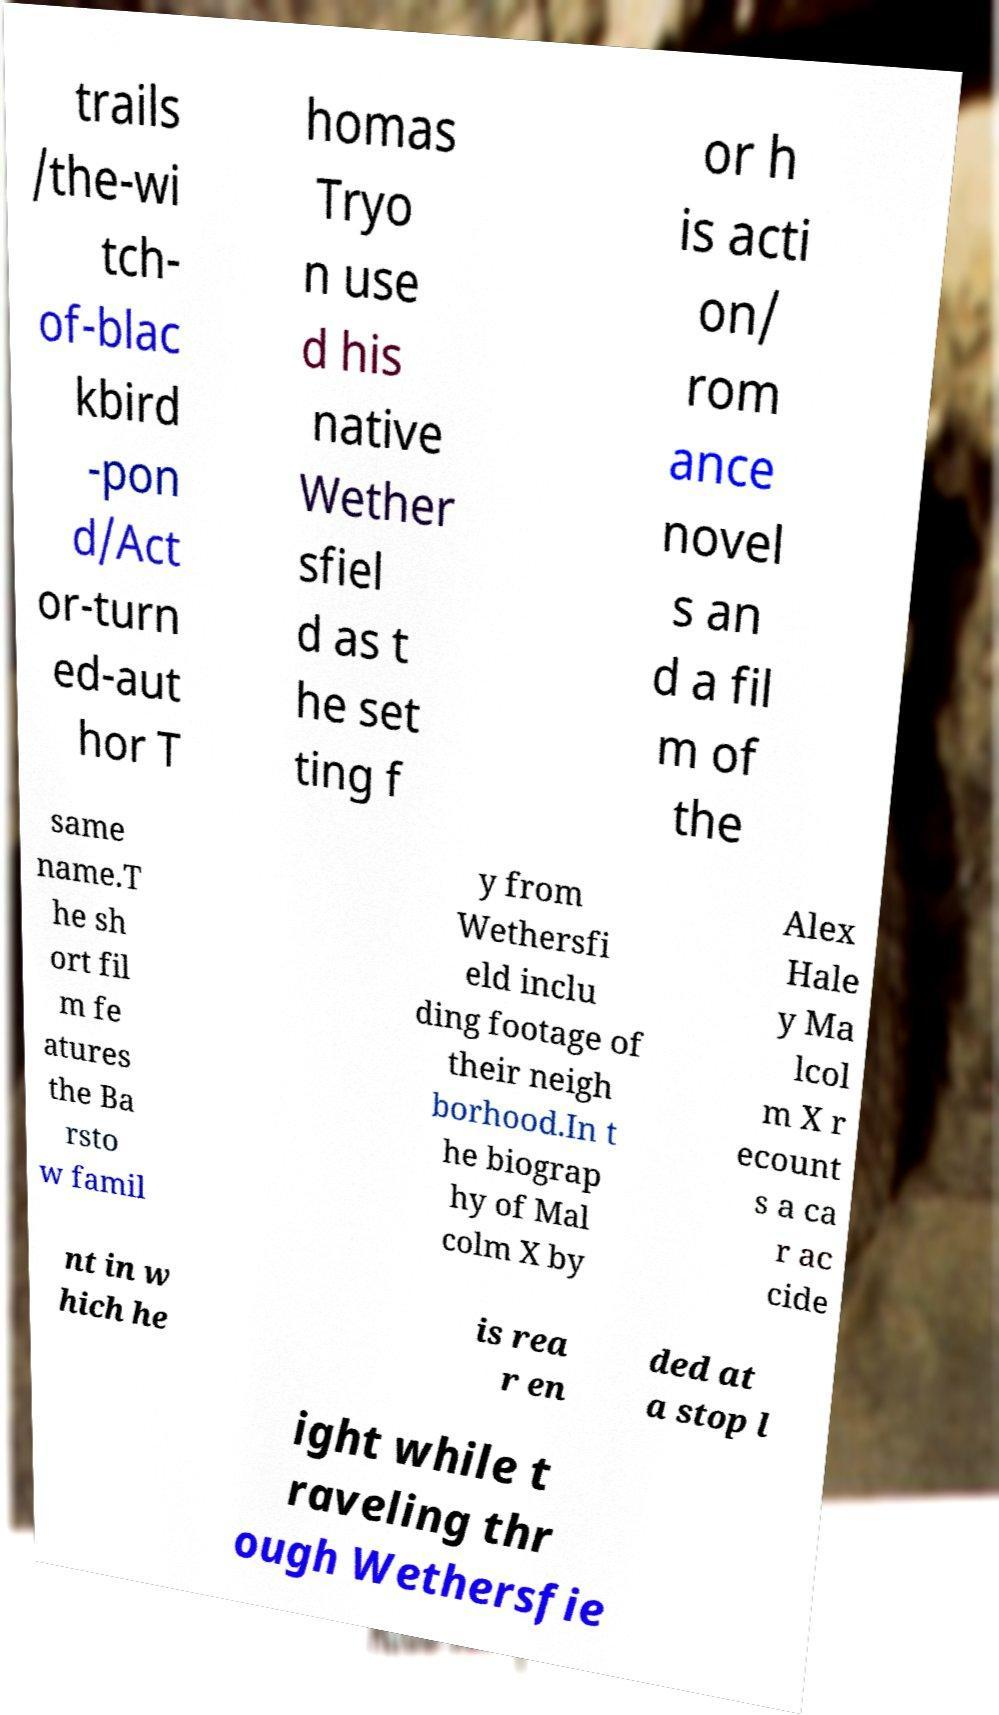Please read and relay the text visible in this image. What does it say? trails /the-wi tch- of-blac kbird -pon d/Act or-turn ed-aut hor T homas Tryo n use d his native Wether sfiel d as t he set ting f or h is acti on/ rom ance novel s an d a fil m of the same name.T he sh ort fil m fe atures the Ba rsto w famil y from Wethersfi eld inclu ding footage of their neigh borhood.In t he biograp hy of Mal colm X by Alex Hale y Ma lcol m X r ecount s a ca r ac cide nt in w hich he is rea r en ded at a stop l ight while t raveling thr ough Wethersfie 